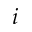<formula> <loc_0><loc_0><loc_500><loc_500>i</formula> 